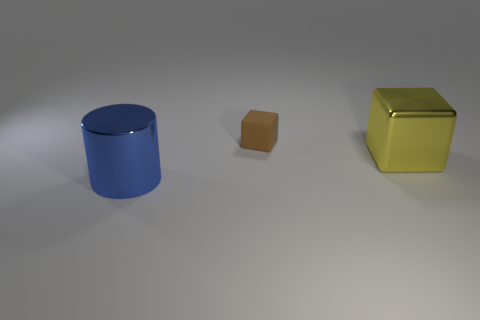Is there any other thing that is the same material as the small brown cube?
Your response must be concise. No. Is the size of the metal object behind the big cylinder the same as the metal thing to the left of the tiny brown object?
Ensure brevity in your answer.  Yes. Are there any other objects of the same shape as the big yellow metallic object?
Your answer should be compact. Yes. Is the number of rubber things to the right of the matte thing less than the number of big yellow metallic spheres?
Keep it short and to the point. No. Does the matte thing have the same shape as the blue metal thing?
Make the answer very short. No. There is a cube on the left side of the yellow thing; how big is it?
Offer a very short reply. Small. The thing that is made of the same material as the yellow cube is what size?
Your response must be concise. Large. Are there fewer small cyan rubber things than matte blocks?
Keep it short and to the point. Yes. What is the material of the object that is the same size as the metal cylinder?
Your answer should be very brief. Metal. Are there more big metal cylinders than metallic things?
Offer a very short reply. No. 